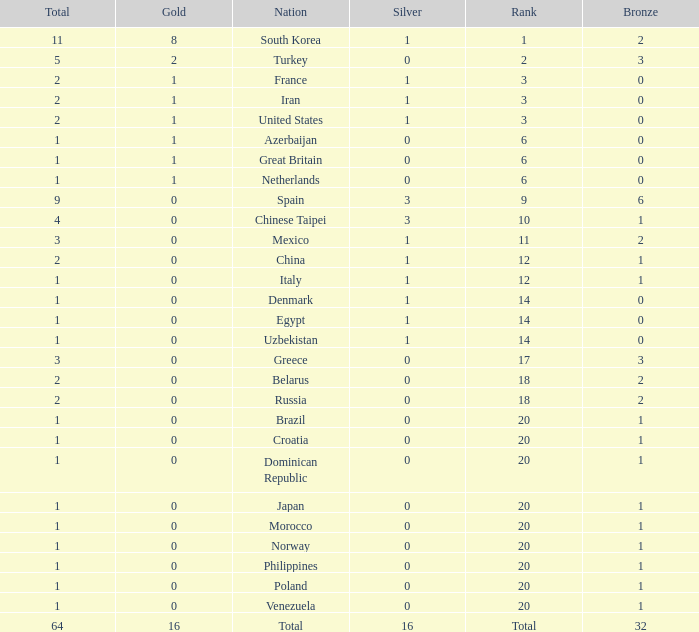How many total silvers does Russia have? 1.0. 